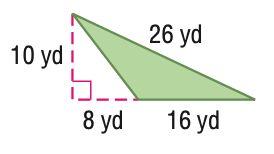Question: Find the perimeter of the figure. Round to the nearest tenth if necessary.
Choices:
A. 54.8
B. 60
C. 80
D. 109.6
Answer with the letter. Answer: A Question: Find the area of the figure. Round to the nearest tenth if necessary.
Choices:
A. 40
B. 80
C. 120
D. 160
Answer with the letter. Answer: B 